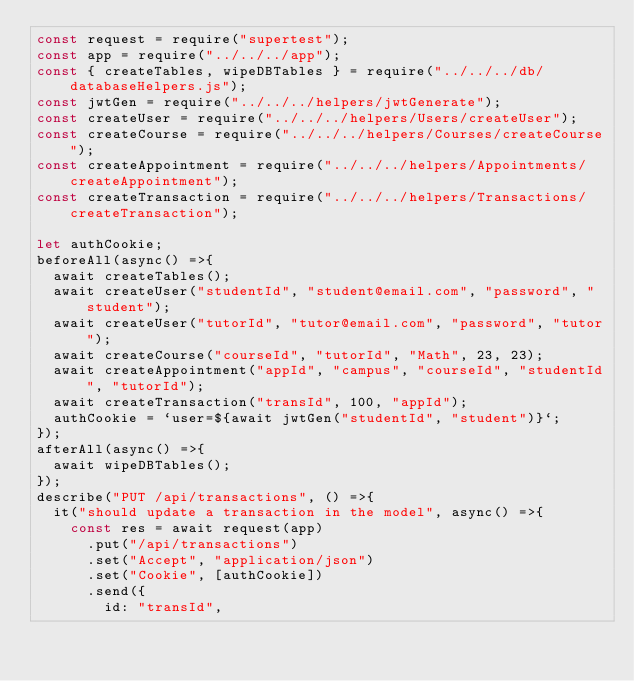Convert code to text. <code><loc_0><loc_0><loc_500><loc_500><_JavaScript_>const request = require("supertest");
const app = require("../../../app");
const { createTables, wipeDBTables } = require("../../../db/databaseHelpers.js");
const jwtGen = require("../../../helpers/jwtGenerate");
const createUser = require("../../../helpers/Users/createUser");
const createCourse = require("../../../helpers/Courses/createCourse");
const createAppointment = require("../../../helpers/Appointments/createAppointment");
const createTransaction = require("../../../helpers/Transactions/createTransaction");

let authCookie;
beforeAll(async() =>{
  await createTables();
  await createUser("studentId", "student@email.com", "password", "student");
  await createUser("tutorId", "tutor@email.com", "password", "tutor");
  await createCourse("courseId", "tutorId", "Math", 23, 23);
  await createAppointment("appId", "campus", "courseId", "studentId", "tutorId");
  await createTransaction("transId", 100, "appId");
  authCookie = `user=${await jwtGen("studentId", "student")}`;
});
afterAll(async() =>{
  await wipeDBTables();
});
describe("PUT /api/transactions", () =>{
  it("should update a transaction in the model", async() =>{
    const res = await request(app)
      .put("/api/transactions")
      .set("Accept", "application/json")
      .set("Cookie", [authCookie])
      .send({
        id: "transId",</code> 